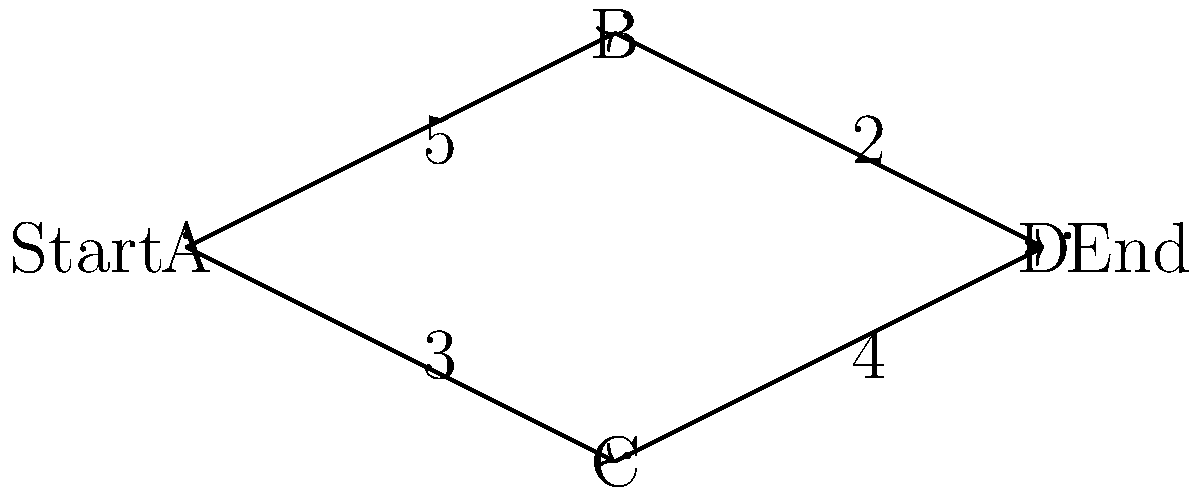In a clinical laboratory, samples flow through a multi-stage diagnostic process represented by the graph above. Each node represents a testing station, and the edges represent the maximum number of samples that can be processed per hour between stations. What is the maximum flow of samples per hour from the start (A) to the end (D) of the process? To solve this problem, we'll use the Ford-Fulkerson algorithm to find the maximum flow in the network:

1. Initialize flow to 0.

2. Find an augmenting path from A to D:
   Path 1: A → B → D (min capacity = 2)
   Increase flow by 2
   Residual graph: A→B: 3, B→D: 0, D→B: 2

3. Find another augmenting path:
   Path 2: A → C → D (min capacity = 3)
   Increase flow by 3
   Residual graph: A→C: 0, C→D: 1, D→C: 3

4. Find another augmenting path:
   Path 3: A → B → D → C → D (min capacity = 1)
   Increase flow by 1
   Residual graph: A→B: 2, B→D: 0, D→B: 3, D→C: 2, C→D: 0

5. No more augmenting paths exist.

The maximum flow is the sum of all flow increases:
$2 + 3 + 1 = 6$ samples per hour.

This result shows that despite individual path capacities being higher, the overall system is limited by the combined capacities of the output edges from A (5 + 3 = 8) and input edges to D (2 + 4 = 6).
Answer: 6 samples per hour 